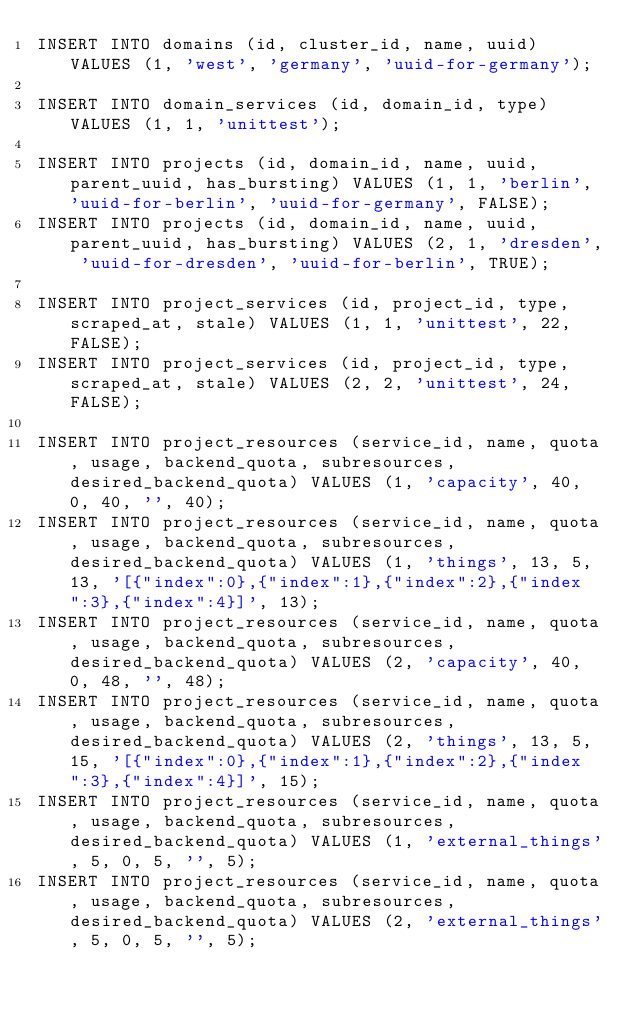<code> <loc_0><loc_0><loc_500><loc_500><_SQL_>INSERT INTO domains (id, cluster_id, name, uuid) VALUES (1, 'west', 'germany', 'uuid-for-germany');

INSERT INTO domain_services (id, domain_id, type) VALUES (1, 1, 'unittest');

INSERT INTO projects (id, domain_id, name, uuid, parent_uuid, has_bursting) VALUES (1, 1, 'berlin', 'uuid-for-berlin', 'uuid-for-germany', FALSE);
INSERT INTO projects (id, domain_id, name, uuid, parent_uuid, has_bursting) VALUES (2, 1, 'dresden', 'uuid-for-dresden', 'uuid-for-berlin', TRUE);

INSERT INTO project_services (id, project_id, type, scraped_at, stale) VALUES (1, 1, 'unittest', 22, FALSE);
INSERT INTO project_services (id, project_id, type, scraped_at, stale) VALUES (2, 2, 'unittest', 24, FALSE);

INSERT INTO project_resources (service_id, name, quota, usage, backend_quota, subresources, desired_backend_quota) VALUES (1, 'capacity', 40, 0, 40, '', 40);
INSERT INTO project_resources (service_id, name, quota, usage, backend_quota, subresources, desired_backend_quota) VALUES (1, 'things', 13, 5, 13, '[{"index":0},{"index":1},{"index":2},{"index":3},{"index":4}]', 13);
INSERT INTO project_resources (service_id, name, quota, usage, backend_quota, subresources, desired_backend_quota) VALUES (2, 'capacity', 40, 0, 48, '', 48);
INSERT INTO project_resources (service_id, name, quota, usage, backend_quota, subresources, desired_backend_quota) VALUES (2, 'things', 13, 5, 15, '[{"index":0},{"index":1},{"index":2},{"index":3},{"index":4}]', 15);
INSERT INTO project_resources (service_id, name, quota, usage, backend_quota, subresources, desired_backend_quota) VALUES (1, 'external_things', 5, 0, 5, '', 5);
INSERT INTO project_resources (service_id, name, quota, usage, backend_quota, subresources, desired_backend_quota) VALUES (2, 'external_things', 5, 0, 5, '', 5);
</code> 